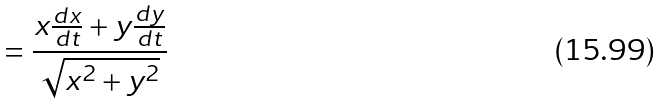Convert formula to latex. <formula><loc_0><loc_0><loc_500><loc_500>= \frac { x \frac { d x } { d t } + y \frac { d y } { d t } } { \sqrt { x ^ { 2 } + y ^ { 2 } } }</formula> 